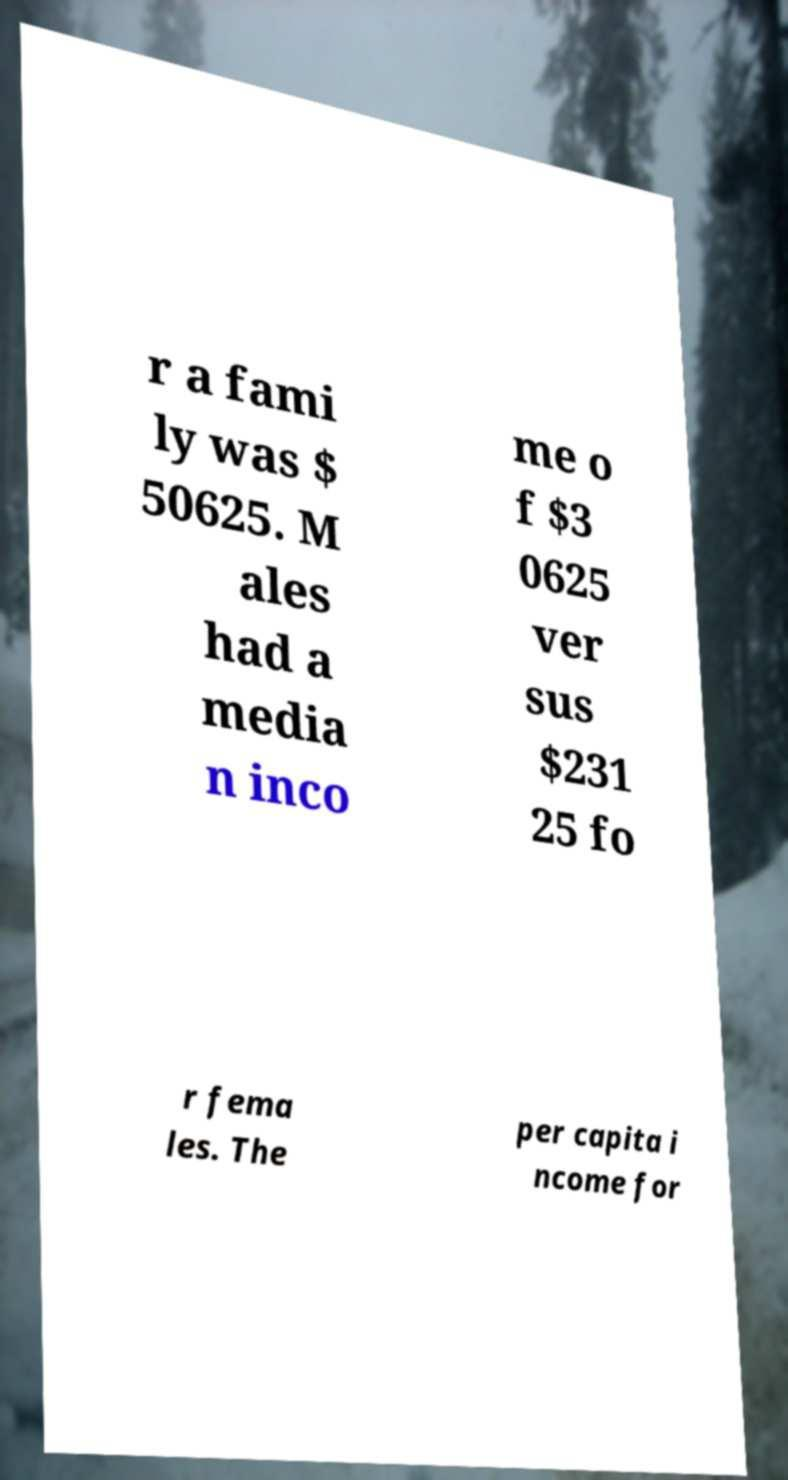Could you assist in decoding the text presented in this image and type it out clearly? r a fami ly was $ 50625. M ales had a media n inco me o f $3 0625 ver sus $231 25 fo r fema les. The per capita i ncome for 